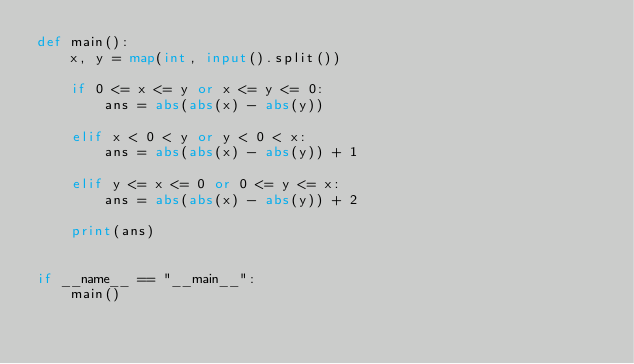Convert code to text. <code><loc_0><loc_0><loc_500><loc_500><_Python_>def main():
    x, y = map(int, input().split())

    if 0 <= x <= y or x <= y <= 0:
        ans = abs(abs(x) - abs(y))

    elif x < 0 < y or y < 0 < x:
        ans = abs(abs(x) - abs(y)) + 1

    elif y <= x <= 0 or 0 <= y <= x:
        ans = abs(abs(x) - abs(y)) + 2

    print(ans)


if __name__ == "__main__":
    main()
</code> 